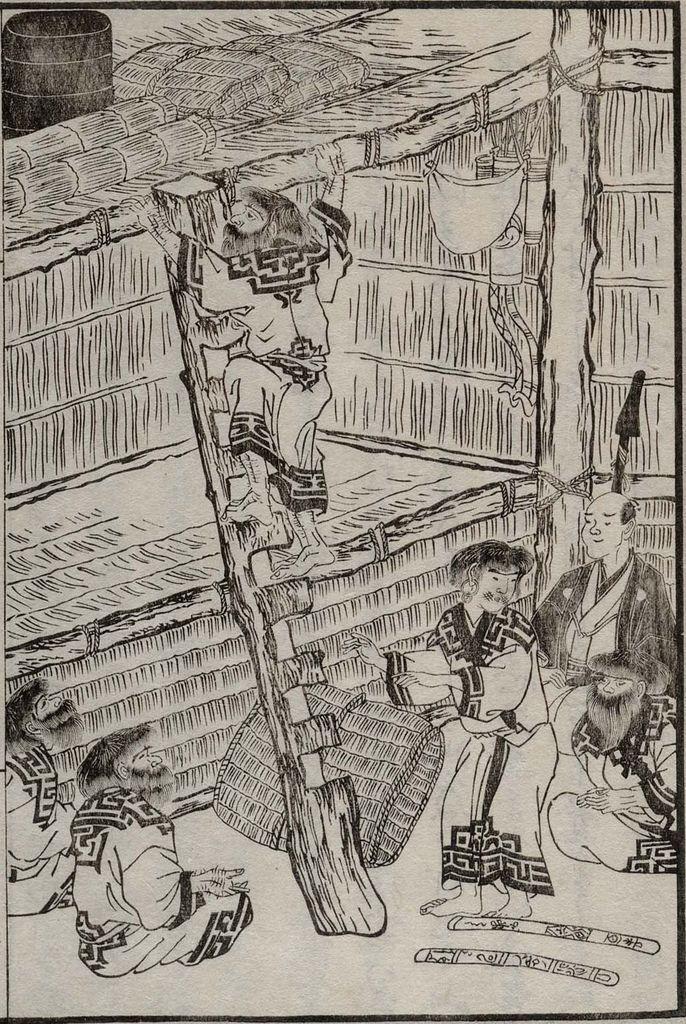Can you describe this image briefly? There are some cartoons presenting in this picture. There is a person on the ladder which is in the middle of the image. 